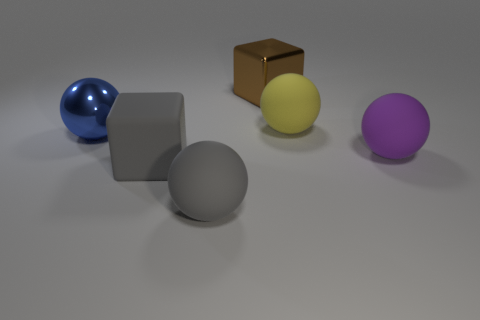Are there the same number of gray blocks right of the large yellow sphere and rubber balls that are right of the large gray rubber sphere?
Ensure brevity in your answer.  No. The gray ball that is the same material as the large yellow thing is what size?
Keep it short and to the point. Large. What color is the shiny cube?
Give a very brief answer. Brown. What number of large objects have the same color as the large shiny block?
Provide a short and direct response. 0. There is a gray ball that is the same size as the yellow rubber thing; what material is it?
Offer a terse response. Rubber. There is a large ball to the left of the gray block; is there a rubber thing that is in front of it?
Offer a terse response. Yes. How many other objects are there of the same color as the matte cube?
Make the answer very short. 1. What is the size of the gray rubber ball?
Offer a terse response. Large. Are any tiny red rubber things visible?
Offer a terse response. No. Is the number of balls that are on the left side of the big brown metal thing greater than the number of purple balls that are left of the large gray block?
Offer a very short reply. Yes. 